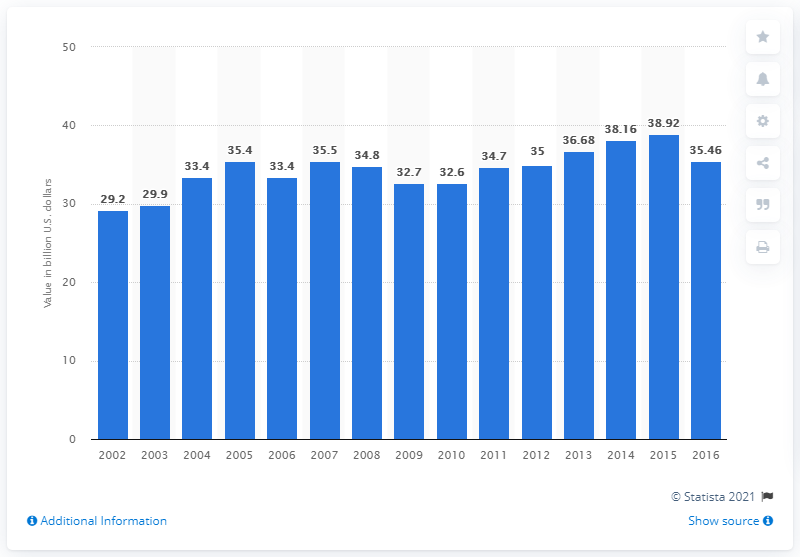List a handful of essential elements in this visual. In 2016, the value of soft drink product shipment in the United States was 35.46 billion dollars. 